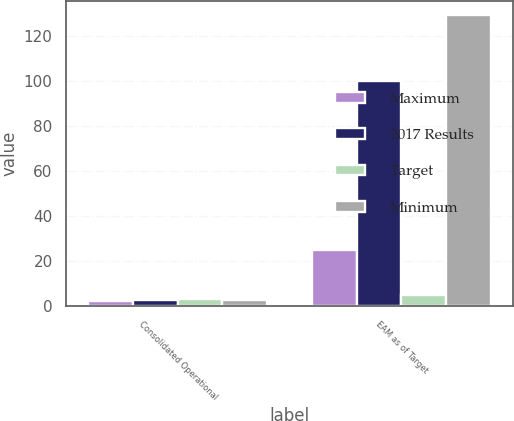Convert chart to OTSL. <chart><loc_0><loc_0><loc_500><loc_500><stacked_bar_chart><ecel><fcel>Consolidated Operational<fcel>EAM as of Target<nl><fcel>Maximum<fcel>2.6<fcel>25<nl><fcel>2017 Results<fcel>3<fcel>100<nl><fcel>Target<fcel>3.4<fcel>5.05<nl><fcel>Minimum<fcel>2.77<fcel>129<nl></chart> 